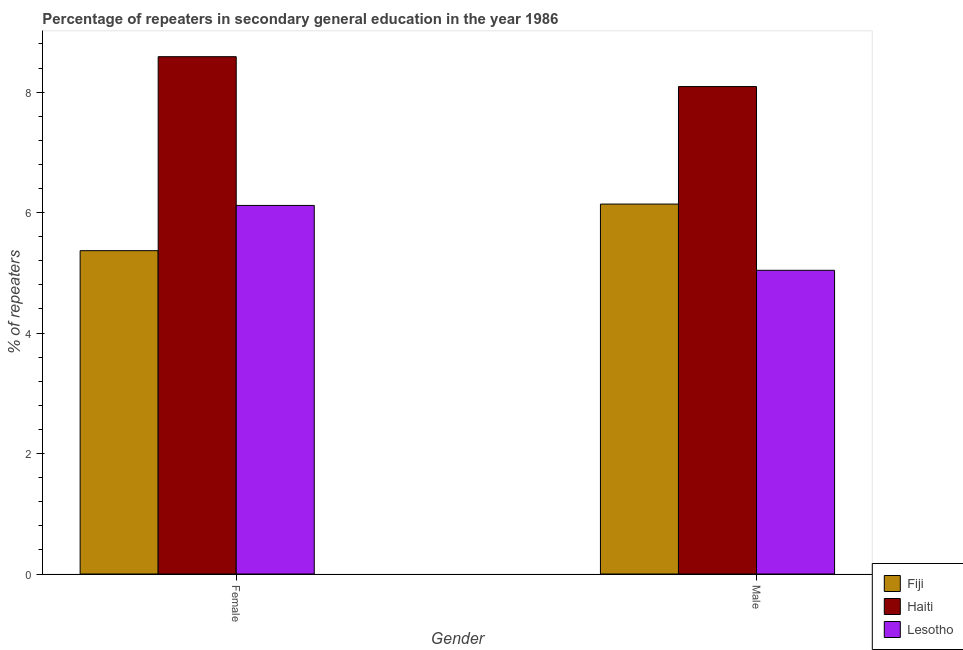Are the number of bars per tick equal to the number of legend labels?
Give a very brief answer. Yes. Are the number of bars on each tick of the X-axis equal?
Your answer should be very brief. Yes. How many bars are there on the 1st tick from the left?
Your answer should be compact. 3. How many bars are there on the 1st tick from the right?
Provide a succinct answer. 3. What is the percentage of male repeaters in Lesotho?
Offer a terse response. 5.04. Across all countries, what is the maximum percentage of male repeaters?
Offer a very short reply. 8.09. Across all countries, what is the minimum percentage of female repeaters?
Your response must be concise. 5.37. In which country was the percentage of male repeaters maximum?
Make the answer very short. Haiti. In which country was the percentage of male repeaters minimum?
Provide a short and direct response. Lesotho. What is the total percentage of male repeaters in the graph?
Your answer should be compact. 19.28. What is the difference between the percentage of female repeaters in Haiti and that in Lesotho?
Your answer should be very brief. 2.47. What is the difference between the percentage of male repeaters in Lesotho and the percentage of female repeaters in Haiti?
Offer a very short reply. -3.55. What is the average percentage of male repeaters per country?
Your response must be concise. 6.43. What is the difference between the percentage of male repeaters and percentage of female repeaters in Lesotho?
Give a very brief answer. -1.08. In how many countries, is the percentage of female repeaters greater than 4.4 %?
Provide a succinct answer. 3. What is the ratio of the percentage of female repeaters in Haiti to that in Fiji?
Keep it short and to the point. 1.6. Is the percentage of female repeaters in Lesotho less than that in Fiji?
Your response must be concise. No. What does the 1st bar from the left in Male represents?
Keep it short and to the point. Fiji. What does the 1st bar from the right in Male represents?
Offer a very short reply. Lesotho. How many countries are there in the graph?
Offer a very short reply. 3. What is the difference between two consecutive major ticks on the Y-axis?
Provide a short and direct response. 2. Does the graph contain grids?
Your answer should be compact. No. Where does the legend appear in the graph?
Your answer should be very brief. Bottom right. How are the legend labels stacked?
Make the answer very short. Vertical. What is the title of the graph?
Provide a short and direct response. Percentage of repeaters in secondary general education in the year 1986. What is the label or title of the Y-axis?
Your answer should be compact. % of repeaters. What is the % of repeaters of Fiji in Female?
Keep it short and to the point. 5.37. What is the % of repeaters of Haiti in Female?
Offer a very short reply. 8.59. What is the % of repeaters in Lesotho in Female?
Your answer should be very brief. 6.12. What is the % of repeaters in Fiji in Male?
Your answer should be very brief. 6.14. What is the % of repeaters in Haiti in Male?
Ensure brevity in your answer.  8.09. What is the % of repeaters in Lesotho in Male?
Make the answer very short. 5.04. Across all Gender, what is the maximum % of repeaters of Fiji?
Give a very brief answer. 6.14. Across all Gender, what is the maximum % of repeaters in Haiti?
Ensure brevity in your answer.  8.59. Across all Gender, what is the maximum % of repeaters of Lesotho?
Provide a succinct answer. 6.12. Across all Gender, what is the minimum % of repeaters in Fiji?
Give a very brief answer. 5.37. Across all Gender, what is the minimum % of repeaters in Haiti?
Offer a very short reply. 8.09. Across all Gender, what is the minimum % of repeaters of Lesotho?
Your answer should be compact. 5.04. What is the total % of repeaters in Fiji in the graph?
Keep it short and to the point. 11.51. What is the total % of repeaters in Haiti in the graph?
Your response must be concise. 16.68. What is the total % of repeaters of Lesotho in the graph?
Offer a very short reply. 11.16. What is the difference between the % of repeaters in Fiji in Female and that in Male?
Provide a short and direct response. -0.77. What is the difference between the % of repeaters of Haiti in Female and that in Male?
Your response must be concise. 0.5. What is the difference between the % of repeaters in Lesotho in Female and that in Male?
Provide a short and direct response. 1.08. What is the difference between the % of repeaters in Fiji in Female and the % of repeaters in Haiti in Male?
Your answer should be very brief. -2.72. What is the difference between the % of repeaters in Fiji in Female and the % of repeaters in Lesotho in Male?
Provide a succinct answer. 0.33. What is the difference between the % of repeaters in Haiti in Female and the % of repeaters in Lesotho in Male?
Make the answer very short. 3.55. What is the average % of repeaters in Fiji per Gender?
Give a very brief answer. 5.75. What is the average % of repeaters in Haiti per Gender?
Offer a very short reply. 8.34. What is the average % of repeaters in Lesotho per Gender?
Offer a terse response. 5.58. What is the difference between the % of repeaters in Fiji and % of repeaters in Haiti in Female?
Provide a short and direct response. -3.22. What is the difference between the % of repeaters in Fiji and % of repeaters in Lesotho in Female?
Your answer should be very brief. -0.75. What is the difference between the % of repeaters in Haiti and % of repeaters in Lesotho in Female?
Your response must be concise. 2.47. What is the difference between the % of repeaters of Fiji and % of repeaters of Haiti in Male?
Offer a terse response. -1.95. What is the difference between the % of repeaters of Fiji and % of repeaters of Lesotho in Male?
Your response must be concise. 1.1. What is the difference between the % of repeaters of Haiti and % of repeaters of Lesotho in Male?
Make the answer very short. 3.05. What is the ratio of the % of repeaters in Fiji in Female to that in Male?
Provide a succinct answer. 0.87. What is the ratio of the % of repeaters in Haiti in Female to that in Male?
Your answer should be compact. 1.06. What is the ratio of the % of repeaters in Lesotho in Female to that in Male?
Your answer should be compact. 1.21. What is the difference between the highest and the second highest % of repeaters in Fiji?
Ensure brevity in your answer.  0.77. What is the difference between the highest and the second highest % of repeaters in Haiti?
Offer a terse response. 0.5. What is the difference between the highest and the second highest % of repeaters in Lesotho?
Keep it short and to the point. 1.08. What is the difference between the highest and the lowest % of repeaters in Fiji?
Your response must be concise. 0.77. What is the difference between the highest and the lowest % of repeaters of Haiti?
Ensure brevity in your answer.  0.5. What is the difference between the highest and the lowest % of repeaters of Lesotho?
Offer a very short reply. 1.08. 